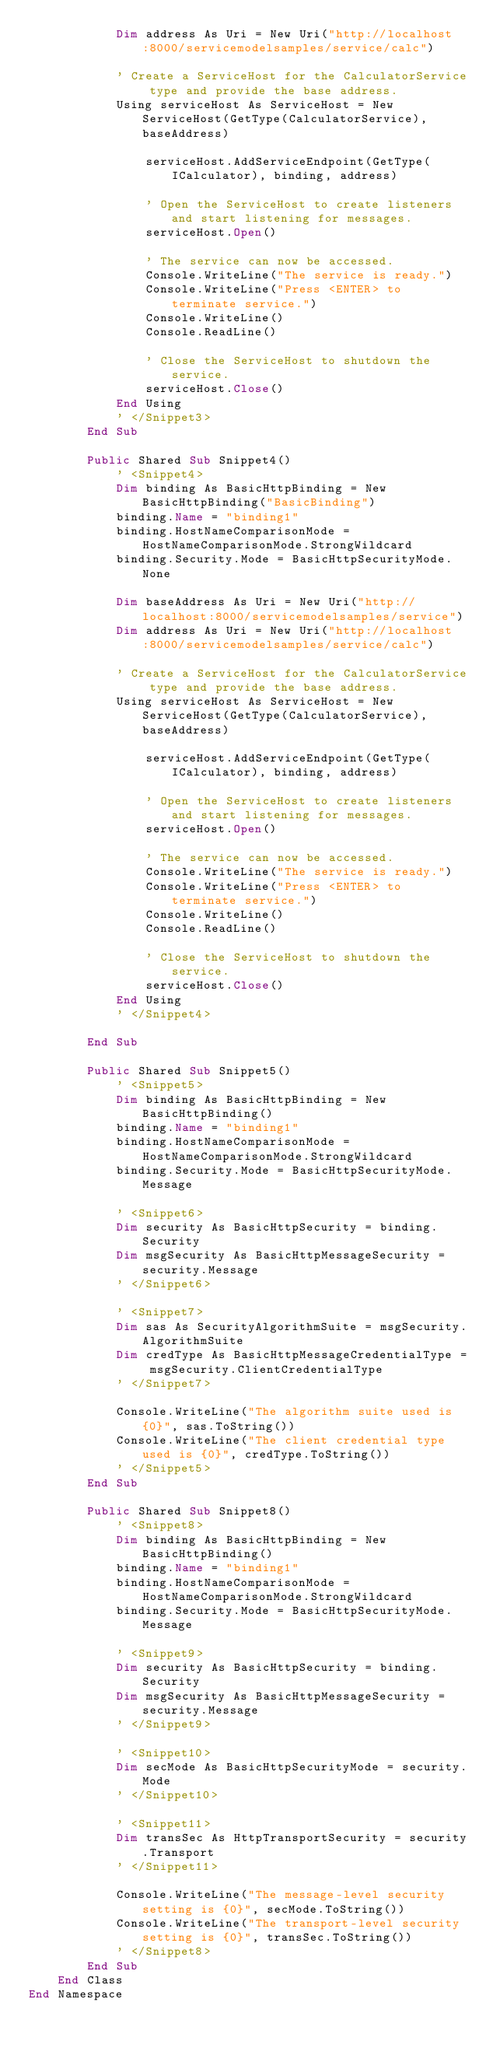Convert code to text. <code><loc_0><loc_0><loc_500><loc_500><_VisualBasic_>            Dim address As Uri = New Uri("http://localhost:8000/servicemodelsamples/service/calc")

            ' Create a ServiceHost for the CalculatorService type and provide the base address.
            Using serviceHost As ServiceHost = New ServiceHost(GetType(CalculatorService), baseAddress)

                serviceHost.AddServiceEndpoint(GetType(ICalculator), binding, address)

                ' Open the ServiceHost to create listeners and start listening for messages.
                serviceHost.Open()

                ' The service can now be accessed.
                Console.WriteLine("The service is ready.")
                Console.WriteLine("Press <ENTER> to terminate service.")
                Console.WriteLine()
                Console.ReadLine()

                ' Close the ServiceHost to shutdown the service.
                serviceHost.Close()
            End Using
            ' </Snippet3>
        End Sub

        Public Shared Sub Snippet4()
            ' <Snippet4>
            Dim binding As BasicHttpBinding = New BasicHttpBinding("BasicBinding")
            binding.Name = "binding1"
            binding.HostNameComparisonMode = HostNameComparisonMode.StrongWildcard
            binding.Security.Mode = BasicHttpSecurityMode.None

            Dim baseAddress As Uri = New Uri("http://localhost:8000/servicemodelsamples/service")
            Dim address As Uri = New Uri("http://localhost:8000/servicemodelsamples/service/calc")

            ' Create a ServiceHost for the CalculatorService type and provide the base address.
            Using serviceHost As ServiceHost = New ServiceHost(GetType(CalculatorService), baseAddress)

                serviceHost.AddServiceEndpoint(GetType(ICalculator), binding, address)

                ' Open the ServiceHost to create listeners and start listening for messages.
                serviceHost.Open()

                ' The service can now be accessed.
                Console.WriteLine("The service is ready.")
                Console.WriteLine("Press <ENTER> to terminate service.")
                Console.WriteLine()
                Console.ReadLine()

                ' Close the ServiceHost to shutdown the service.
                serviceHost.Close()
            End Using
            ' </Snippet4>

        End Sub

        Public Shared Sub Snippet5()
            ' <Snippet5>
            Dim binding As BasicHttpBinding = New BasicHttpBinding()
            binding.Name = "binding1"
            binding.HostNameComparisonMode = HostNameComparisonMode.StrongWildcard
            binding.Security.Mode = BasicHttpSecurityMode.Message

            ' <Snippet6>
            Dim security As BasicHttpSecurity = binding.Security
            Dim msgSecurity As BasicHttpMessageSecurity = security.Message
            ' </Snippet6>

            ' <Snippet7>
            Dim sas As SecurityAlgorithmSuite = msgSecurity.AlgorithmSuite
            Dim credType As BasicHttpMessageCredentialType = msgSecurity.ClientCredentialType
            ' </Snippet7>

            Console.WriteLine("The algorithm suite used is {0}", sas.ToString())
            Console.WriteLine("The client credential type used is {0}", credType.ToString())
            ' </Snippet5>
        End Sub

        Public Shared Sub Snippet8()
            ' <Snippet8>
            Dim binding As BasicHttpBinding = New BasicHttpBinding()
            binding.Name = "binding1"
            binding.HostNameComparisonMode = HostNameComparisonMode.StrongWildcard
            binding.Security.Mode = BasicHttpSecurityMode.Message

            ' <Snippet9>
            Dim security As BasicHttpSecurity = binding.Security
            Dim msgSecurity As BasicHttpMessageSecurity = security.Message
            ' </Snippet9>

            ' <Snippet10>
            Dim secMode As BasicHttpSecurityMode = security.Mode
            ' </Snippet10>

            ' <Snippet11>
            Dim transSec As HttpTransportSecurity = security.Transport
            ' </Snippet11>

            Console.WriteLine("The message-level security setting is {0}", secMode.ToString())
            Console.WriteLine("The transport-level security setting is {0}", transSec.ToString())
            ' </Snippet8>
        End Sub
    End Class
End Namespace

</code> 